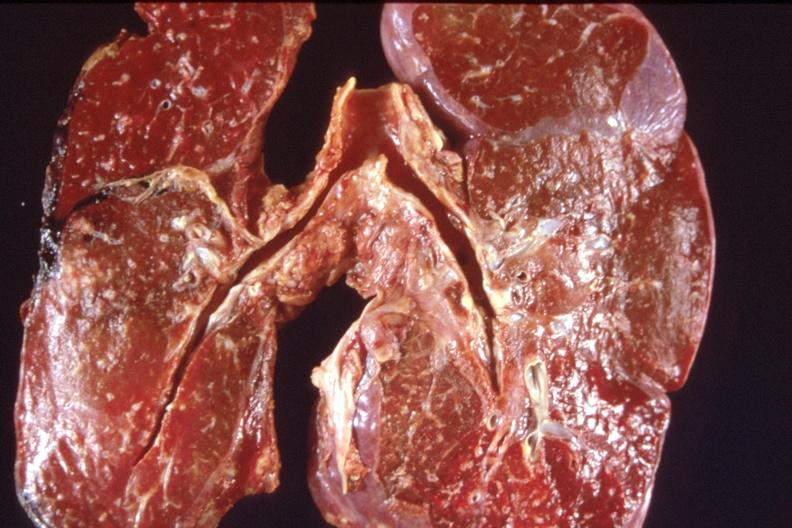does acute peritonitis show lung, pulmonary edema and focal pneumonitis?
Answer the question using a single word or phrase. No 